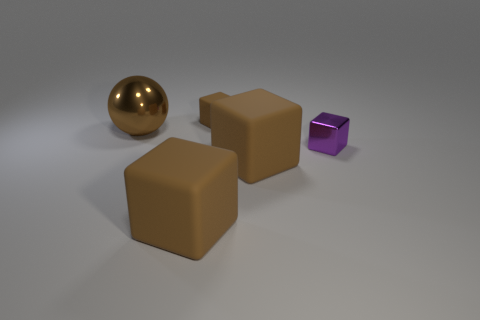Subtract all brown cubes. How many were subtracted if there are1brown cubes left? 2 Subtract all metal blocks. How many blocks are left? 3 Subtract all blocks. How many objects are left? 1 Add 1 small gray balls. How many objects exist? 6 Subtract all brown cubes. How many cubes are left? 1 Subtract 2 blocks. How many blocks are left? 2 Subtract 0 gray cylinders. How many objects are left? 5 Subtract all cyan balls. Subtract all green blocks. How many balls are left? 1 Subtract all green spheres. How many brown blocks are left? 3 Subtract all shiny spheres. Subtract all green cylinders. How many objects are left? 4 